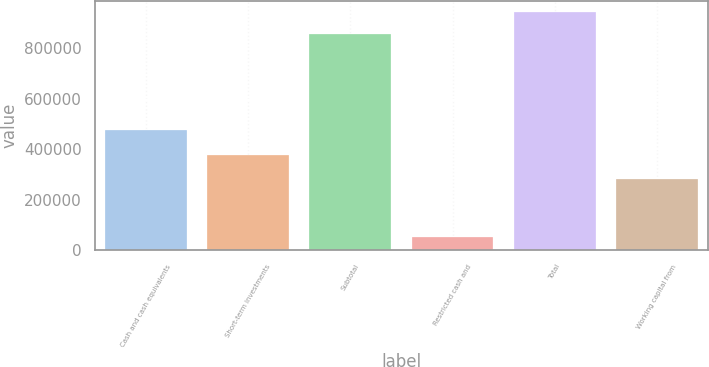Convert chart. <chart><loc_0><loc_0><loc_500><loc_500><bar_chart><fcel>Cash and cash equivalents<fcel>Short-term investments<fcel>Subtotal<fcel>Restricted cash and<fcel>Total<fcel>Working capital from<nl><fcel>476826<fcel>378006<fcel>854832<fcel>50972<fcel>940315<fcel>281659<nl></chart> 